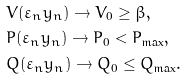Convert formula to latex. <formula><loc_0><loc_0><loc_500><loc_500>& V ( \varepsilon _ { n } y _ { n } ) \rightarrow V _ { 0 } \geq \beta , \\ & P ( \varepsilon _ { n } y _ { n } ) \rightarrow P _ { 0 } < P _ { \max } , \\ & Q ( \varepsilon _ { n } y _ { n } ) \rightarrow Q _ { 0 } \leq Q _ { \max } .</formula> 